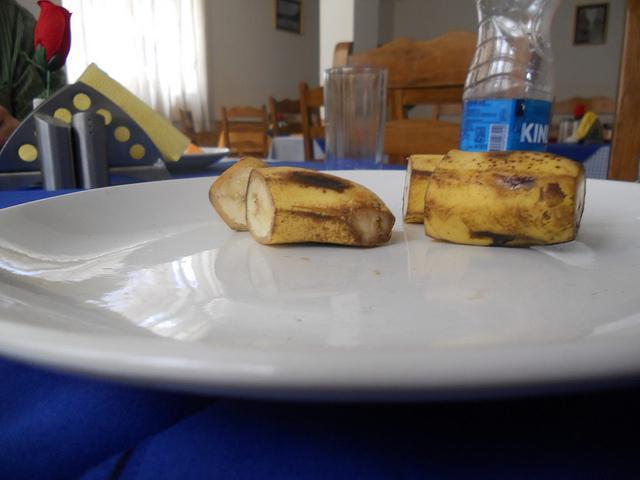How many pieces of bananas do you count?
Give a very brief answer. 4. How many plates are in the picture?
Give a very brief answer. 1. How many jellies are there on the table?
Give a very brief answer. 0. How many plates are there?
Give a very brief answer. 1. How many slices are standing up on their edges?
Give a very brief answer. 0. How many chairs are there?
Give a very brief answer. 2. 